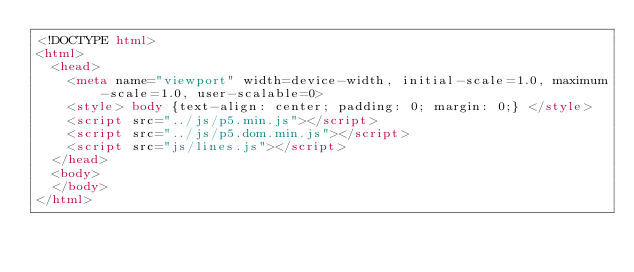<code> <loc_0><loc_0><loc_500><loc_500><_HTML_><!DOCTYPE html>
<html>
  <head>
    <meta name="viewport" width=device-width, initial-scale=1.0, maximum-scale=1.0, user-scalable=0>
    <style> body {text-align: center; padding: 0; margin: 0;} </style>
    <script src="../js/p5.min.js"></script>
    <script src="../js/p5.dom.min.js"></script>
    <script src="js/lines.js"></script>
  </head>
  <body>
  </body>
</html></code> 